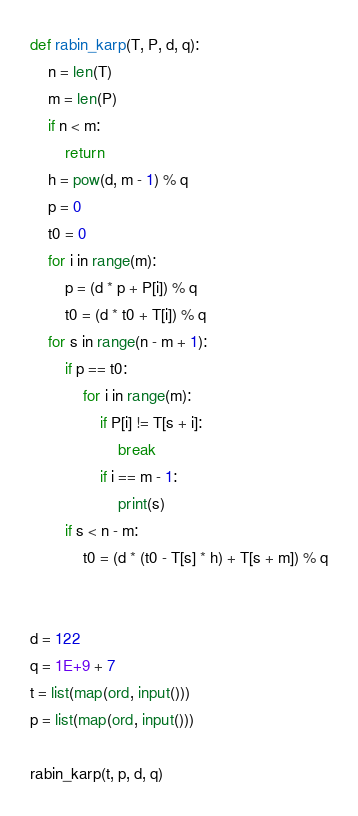<code> <loc_0><loc_0><loc_500><loc_500><_Python_>def rabin_karp(T, P, d, q):
    n = len(T)
    m = len(P)
    if n < m:
        return
    h = pow(d, m - 1) % q
    p = 0
    t0 = 0
    for i in range(m):
        p = (d * p + P[i]) % q
        t0 = (d * t0 + T[i]) % q
    for s in range(n - m + 1):
        if p == t0:
            for i in range(m):
                if P[i] != T[s + i]:
                    break
                if i == m - 1:
                    print(s)
        if s < n - m:
            t0 = (d * (t0 - T[s] * h) + T[s + m]) % q


d = 122
q = 1E+9 + 7
t = list(map(ord, input()))
p = list(map(ord, input()))

rabin_karp(t, p, d, q)
</code> 